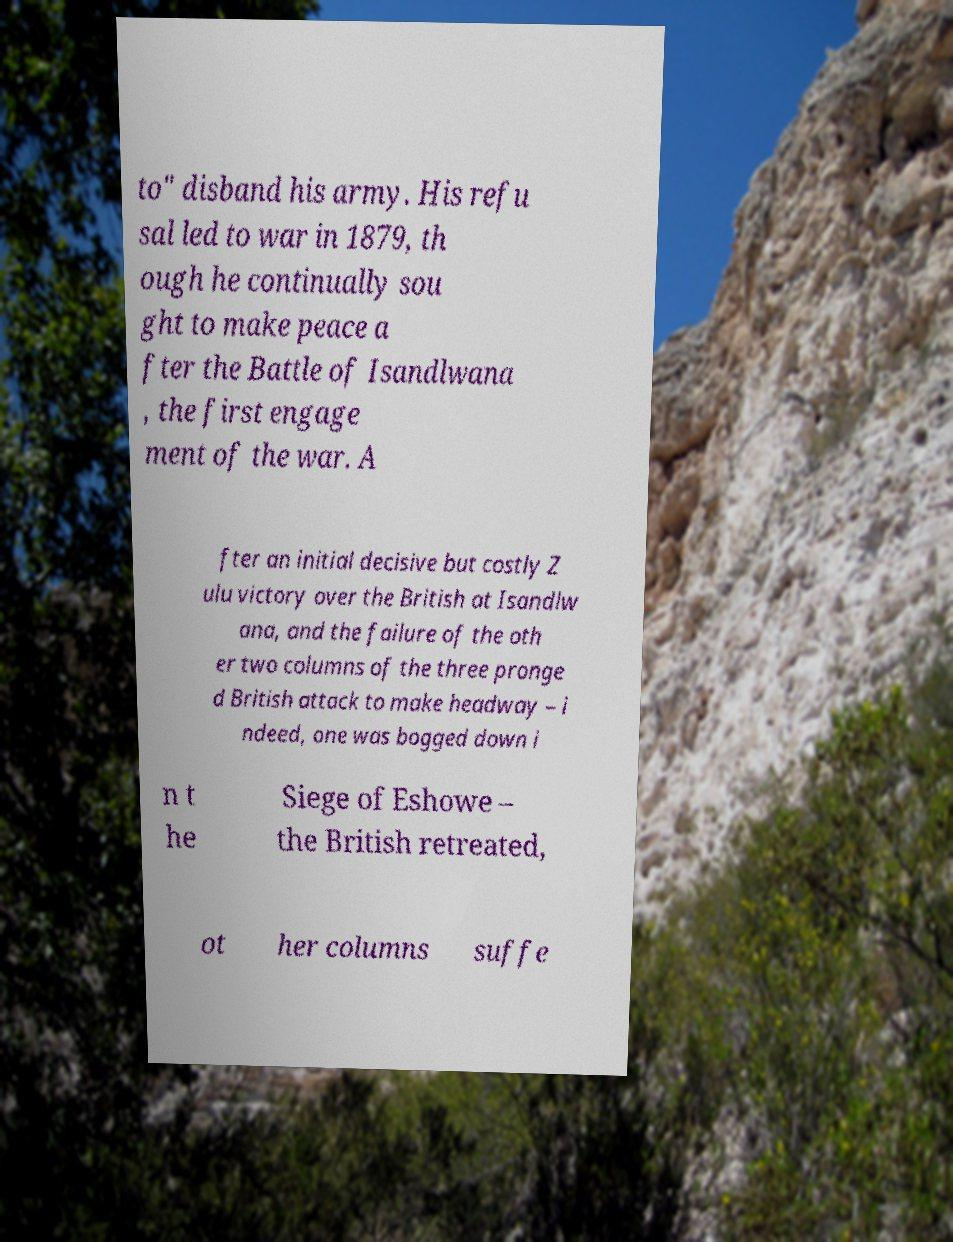Please read and relay the text visible in this image. What does it say? to" disband his army. His refu sal led to war in 1879, th ough he continually sou ght to make peace a fter the Battle of Isandlwana , the first engage ment of the war. A fter an initial decisive but costly Z ulu victory over the British at Isandlw ana, and the failure of the oth er two columns of the three pronge d British attack to make headway – i ndeed, one was bogged down i n t he Siege of Eshowe – the British retreated, ot her columns suffe 